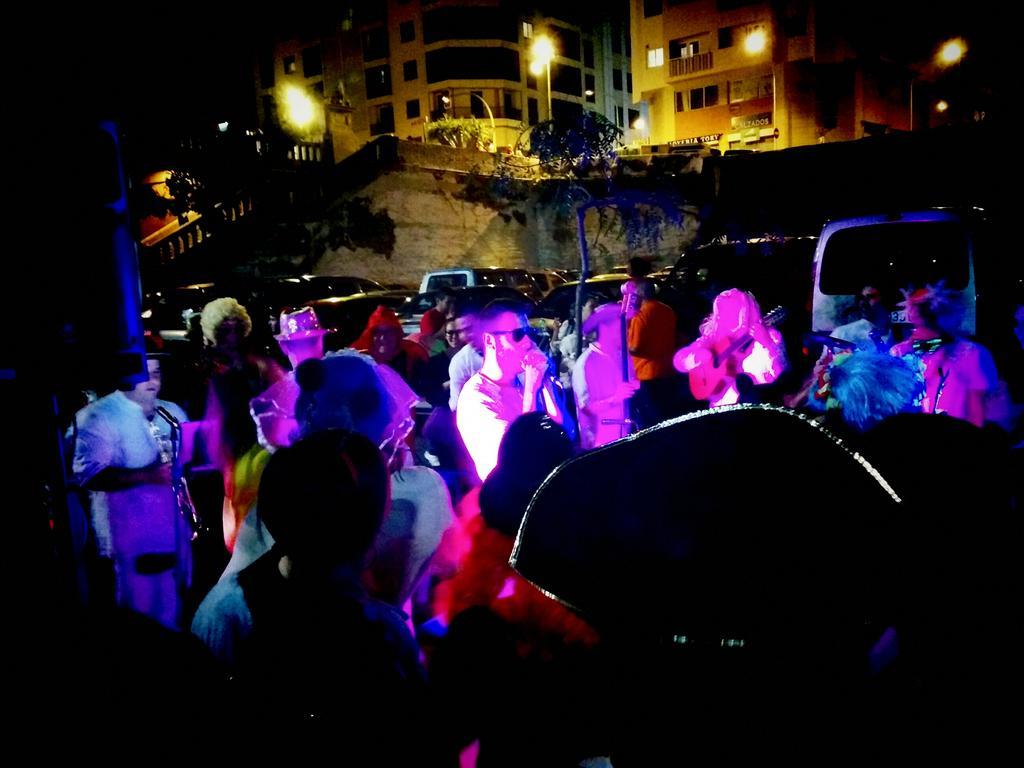Please provide a concise description of this image. This image is taken outdoors. This image is a little dark. In the background there are two buildings. There are a few poles with street lights. There are a few plants. There is a wall. Many vehicles are parked on a ground. There is a railing. In the middle of the image many people are standing on the ground. 